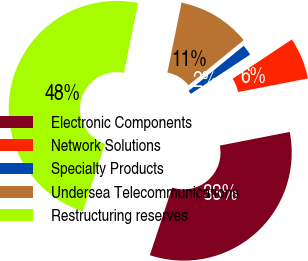Convert chart. <chart><loc_0><loc_0><loc_500><loc_500><pie_chart><fcel>Electronic Components<fcel>Network Solutions<fcel>Specialty Products<fcel>Undersea Telecommunications<fcel>Restructuring reserves<nl><fcel>33.14%<fcel>6.25%<fcel>1.6%<fcel>10.9%<fcel>48.1%<nl></chart> 